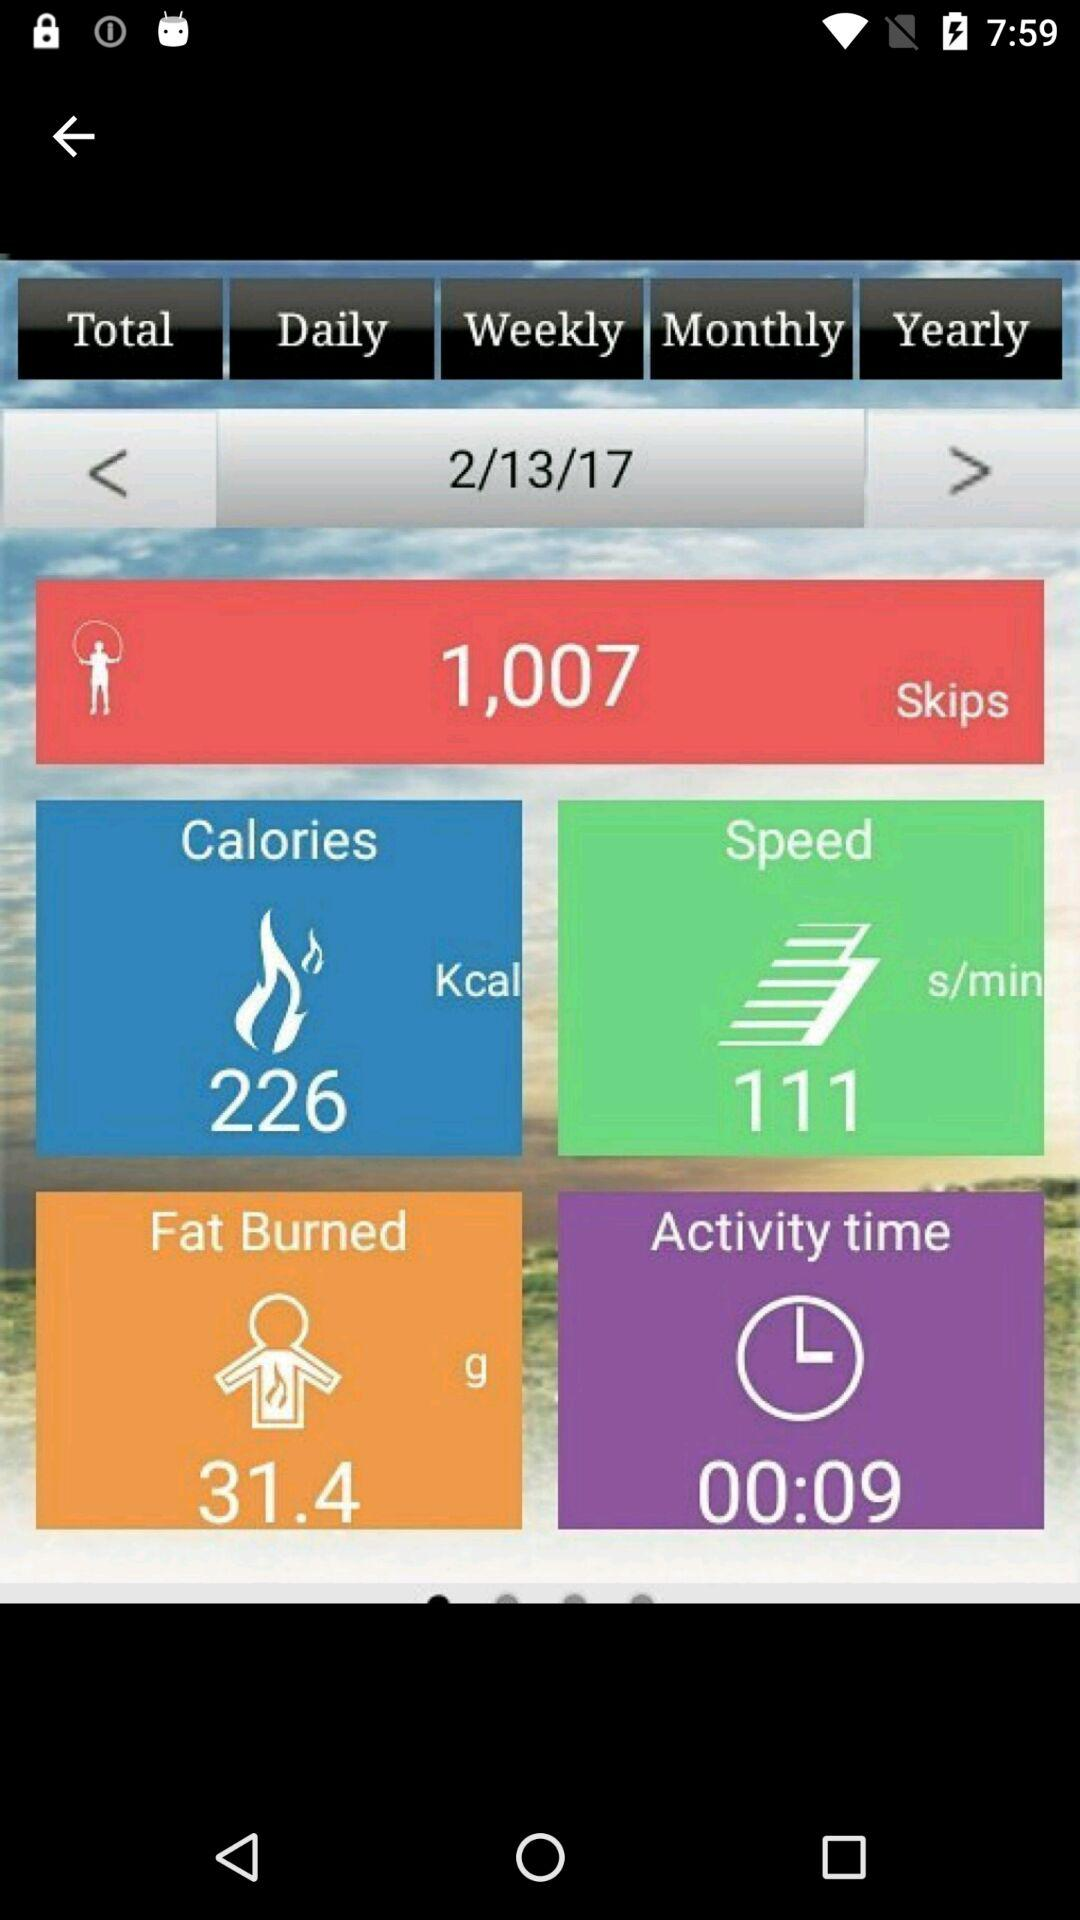At what speed were the skips taken? The skips were taken at the speed of 111 s/min. 